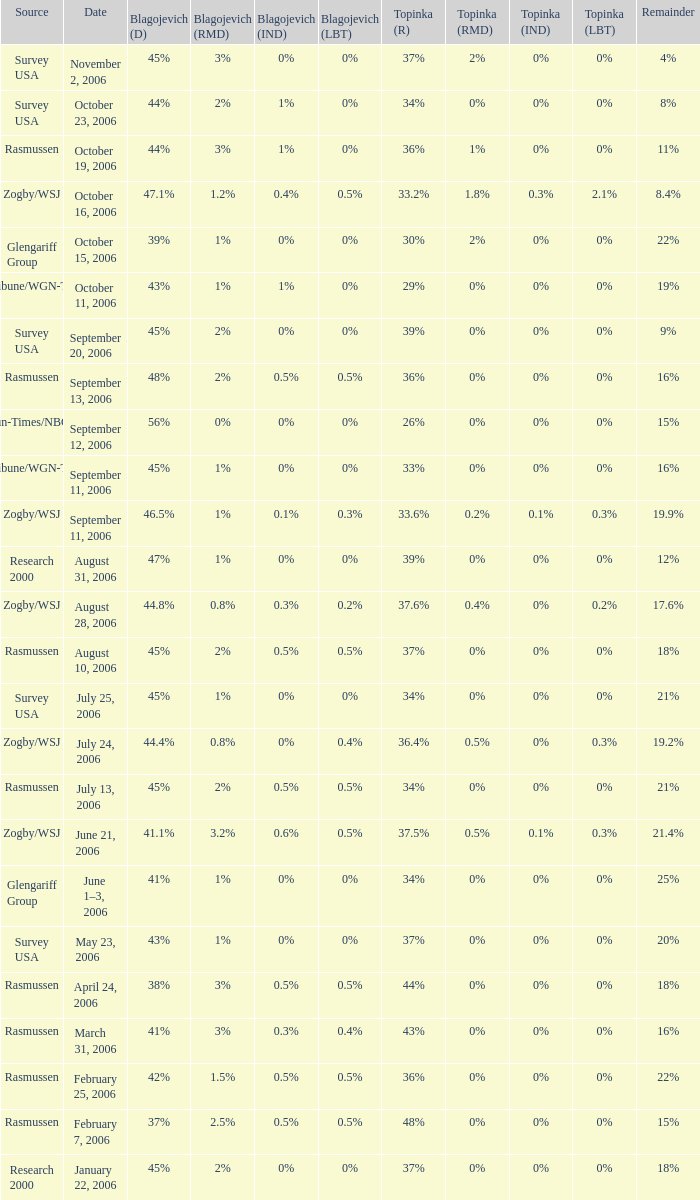Which Blagojevich (D) has a Source of zogby/wsj, and a Topinka (R) of 33.2%? 47.1%. 